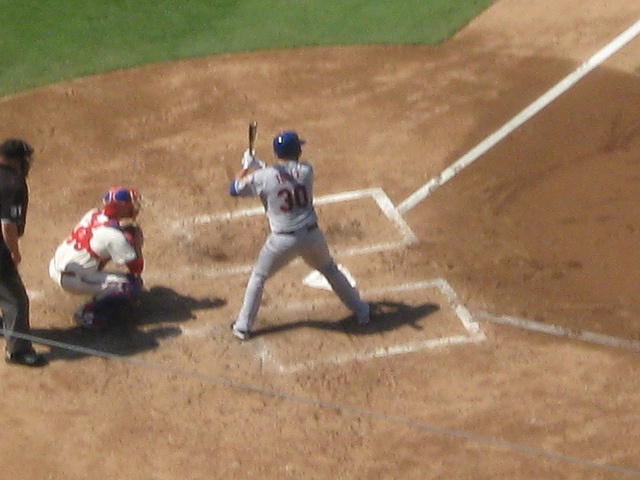Describe the objects in this image and their specific colors. I can see people in darkgreen, gray, darkgray, lightgray, and black tones, people in darkgreen, gray, white, black, and maroon tones, people in darkgreen, black, gray, and maroon tones, baseball glove in darkgreen, maroon, black, and brown tones, and baseball bat in darkgreen, maroon, and gray tones in this image. 